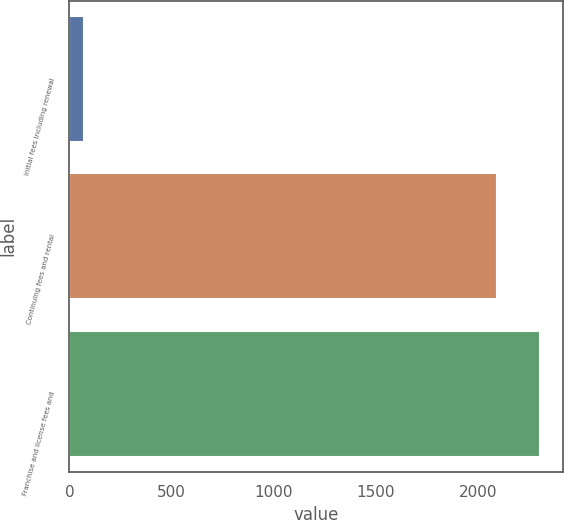<chart> <loc_0><loc_0><loc_500><loc_500><bar_chart><fcel>Initial fees including renewal<fcel>Continuing fees and rental<fcel>Franchise and license fees and<nl><fcel>72<fcel>2095<fcel>2304.5<nl></chart> 